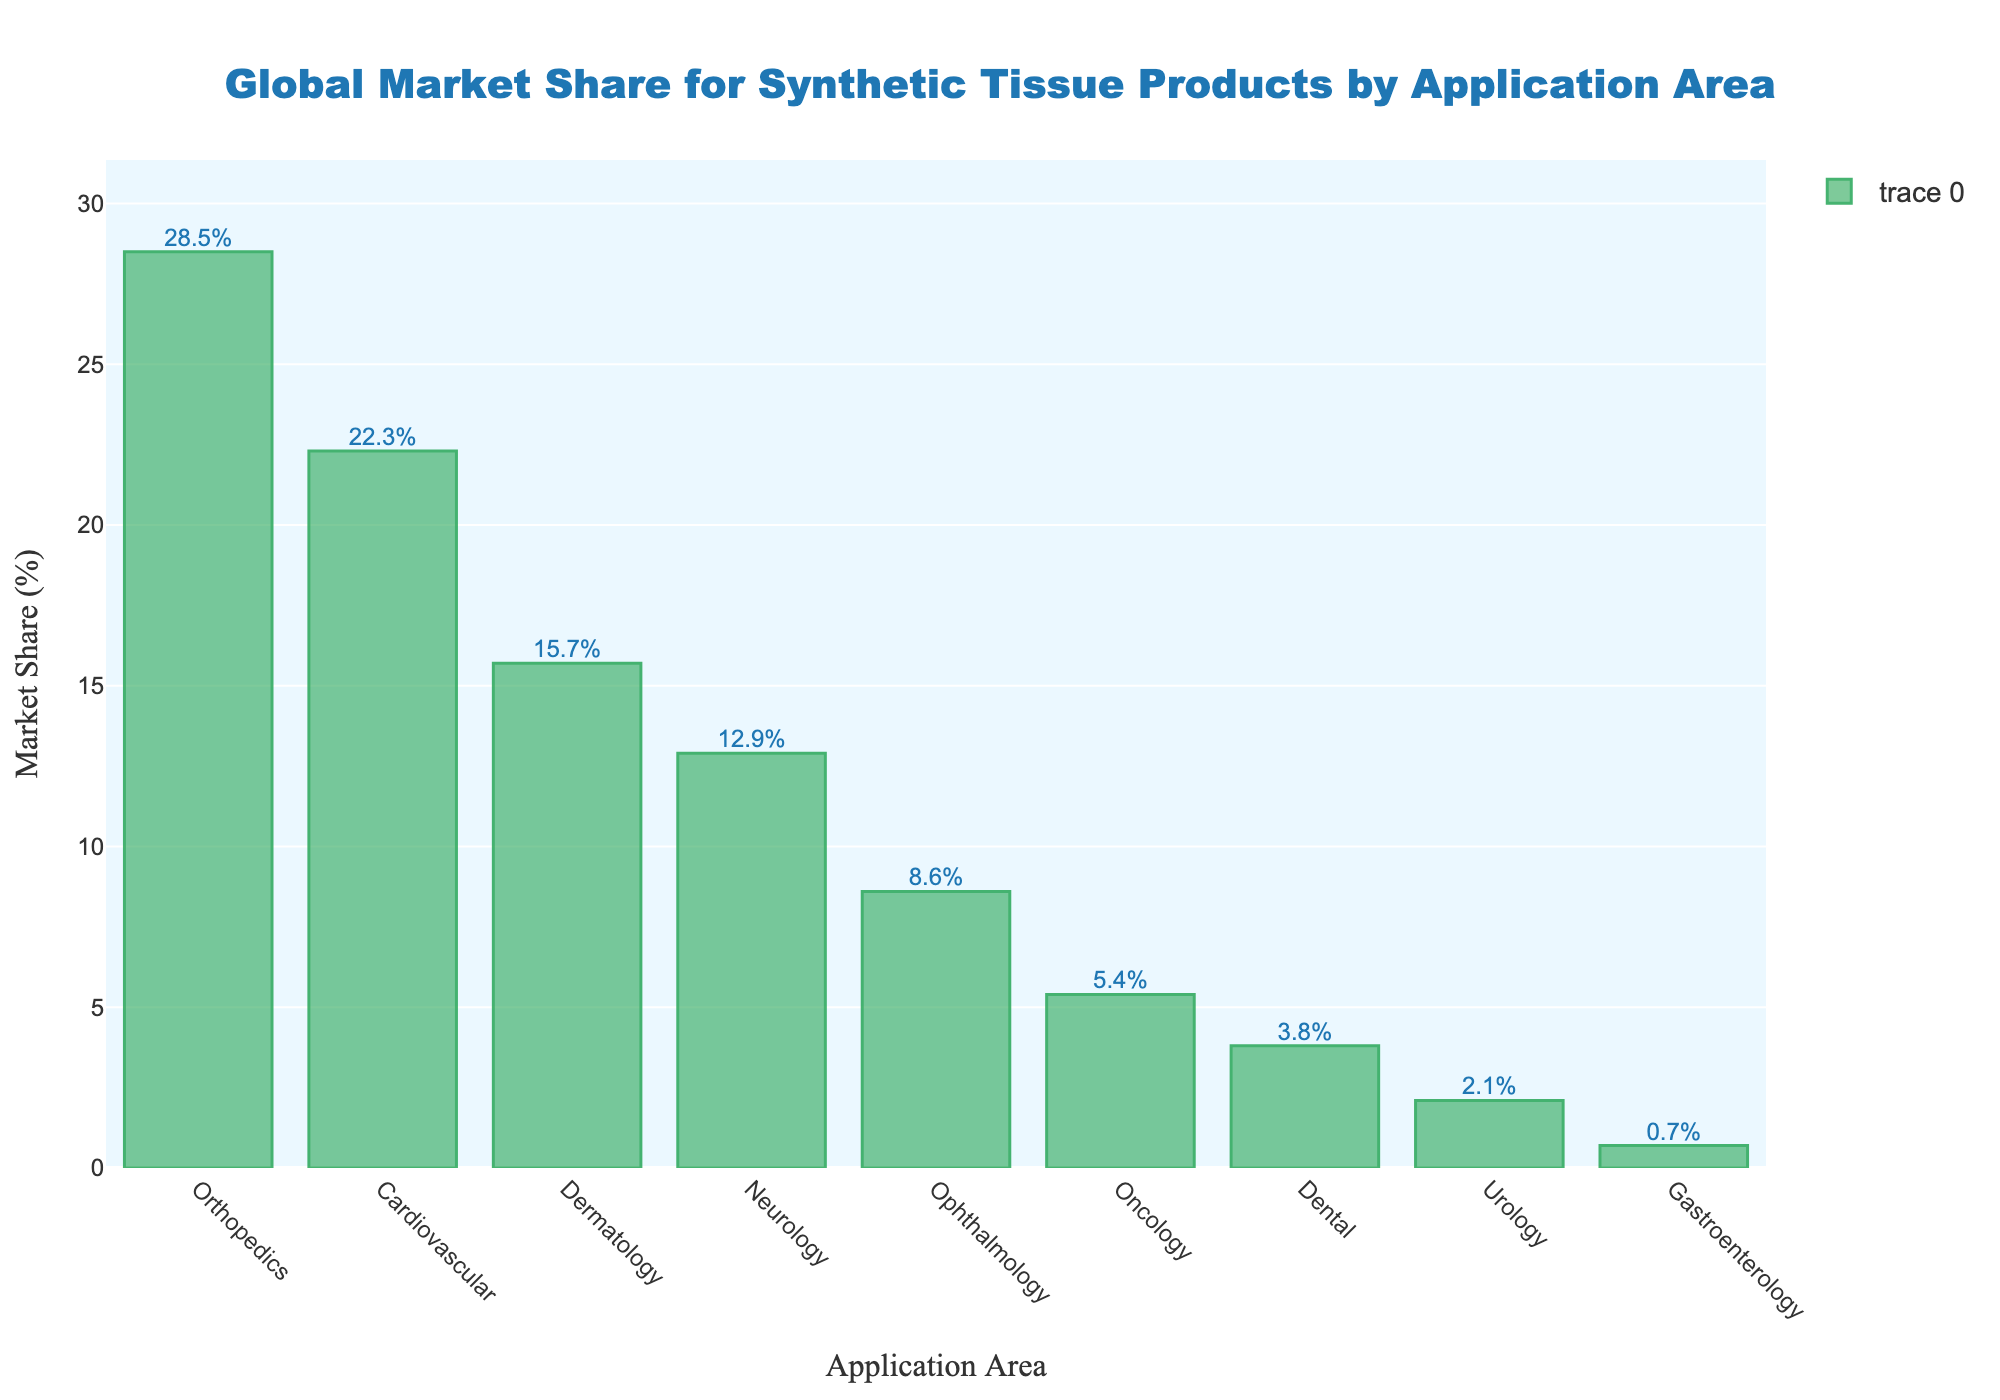What is the combined market share of Orthopedics and Cardiovascular application areas? First, identify the market share of Orthopedics (28.5%) and Cardiovascular (22.3%) from the bar chart. Add these numbers together: 28.5% + 22.3% = 50.8%
Answer: 50.8% Which application area has a lower market share, Dermatology or Neurology? Identify the market share for Dermatology (15.7%) and Neurology (12.9%). Compare these numbers: 15.7% > 12.9%, so Neurology has a lower market share
Answer: Neurology How much higher is the market share for Orthopedics compared to Dermatology? Identify the market share for Orthopedics (28.5%) and Dermatology (15.7%). Subtract Dermatology's share from Orthopedics': 28.5% - 15.7% = 12.8%
Answer: 12.8% What is the median market share value of all application areas? List all market share values: 28.5, 22.3, 15.7, 12.9, 8.6, 5.4, 3.8, 2.1, 0.7. Arrange them: 0.7, 2.1, 3.8, 5.4, 8.6, 12.9, 15.7, 22.3, 28.5. The median is the middle value: 8.6
Answer: 8.6 Which application area has the highest market share? Identify the highest bar in the bar chart. Orthopedics has the highest market share at 28.5%
Answer: Orthopedics What is the difference in market share between the Oncology and Gastroenterology application areas? Identify the market share for Oncology (5.4%) and Gastroenterology (0.7%). Subtract Gastroenterology's share from Oncology's: 5.4% - 0.7% = 4.7%
Answer: 4.7% Is the market share for Neurology greater than 10%? Identify the market share for Neurology (12.9%). Compare it with 10%: 12.9% > 10%
Answer: Yes How many application areas have a market share greater than 10%? Identify the application areas with more than 10% market share: Orthopedics (28.5%), Cardiovascular (22.3%), Dermatology (15.7%), Neurology (12.9%). There are 4 such areas
Answer: 4 What is the total market share of all application areas excluding Orthopedics? Sum the market shares of all areas except Orthopedics (28.5%): 22.3% + 15.7% + 12.9% + 8.6% + 5.4% + 3.8% + 2.1% + 0.7% = 71.5%
Answer: 71.5% Are there more application areas with a market share below 10% or above 10%? Count the areas with market share above 10%: (Orthopedics, Cardiovascular, Dermatology, Neurology) = 4. Count the areas below 10%: (Ophthalmology, Oncology, Dental, Urology, Gastroenterology) = 5. More areas are below 10%
Answer: Below 10% 